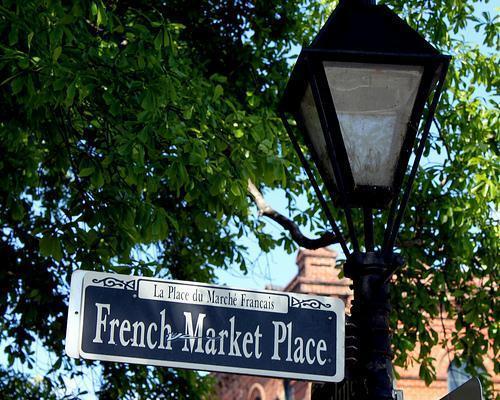How many lamps are there?
Give a very brief answer. 1. 